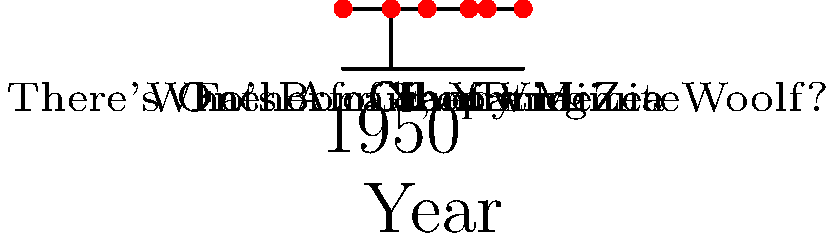Based on the timeline of Elizabeth Taylor's film career shown above, which movie marked her transition from child actress to adult roles and was released closest to the midpoint of her career span depicted here? To answer this question, we need to follow these steps:

1. Identify the range of Elizabeth Taylor's career span shown in the timeline:
   - Earliest film: "There's One Born Every Minute" (1942)
   - Latest film: "X, Y and Zee" (1972)
   - Career span: 1972 - 1942 = 30 years

2. Calculate the midpoint of her career span:
   - Midpoint year: 1942 + (30 / 2) = 1957

3. Examine the films near this midpoint:
   - "Father of the Bride" (1950)
   - "Giant" (1956)
   - "Cleopatra" (1963)

4. Consider which of these films marked her transition to adult roles:
   - "Father of the Bride" was still a somewhat youthful role
   - "Giant" was her first major adult dramatic role
   - "Cleopatra" was well into her adult career

5. Determine which film is closest to the 1957 midpoint and represents the transition:
   - "Giant" (1956) is closest to 1957 and marks her transition to serious adult roles

Therefore, "Giant" is the film that best fits the criteria in the question.
Answer: Giant (1956) 